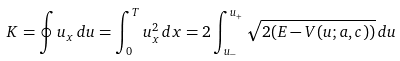<formula> <loc_0><loc_0><loc_500><loc_500>K = \oint u _ { x } \, d u = \int _ { 0 } ^ { T } u _ { x } ^ { 2 } \, d x = 2 \int _ { u _ { - } } ^ { u _ { + } } \sqrt { 2 ( E - V ( u ; a , c ) ) } \, d u</formula> 